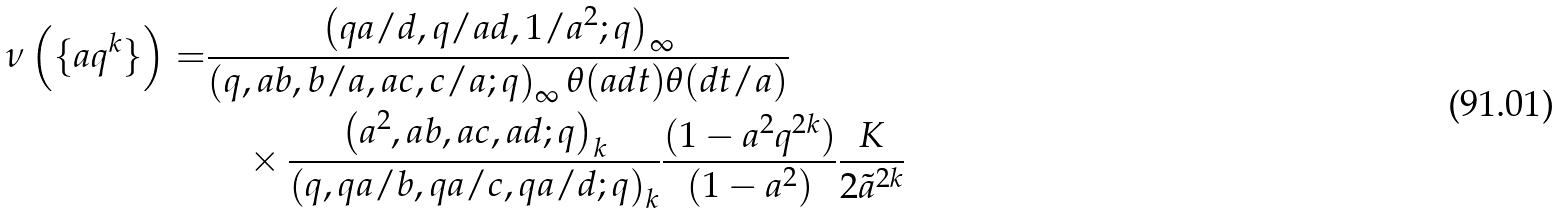Convert formula to latex. <formula><loc_0><loc_0><loc_500><loc_500>\nu \left ( \{ a q ^ { k } \} \right ) = & \frac { \left ( q a / d , q / a d , 1 / a ^ { 2 } ; q \right ) _ { \infty } } { \left ( q , a b , b / a , a c , c / a ; q \right ) _ { \infty } \theta ( a d t ) \theta ( d t / a ) } \\ & \quad \times \frac { \left ( a ^ { 2 } , a b , a c , a d ; q \right ) _ { k } } { \left ( q , q a / b , q a / c , q a / d ; q \right ) _ { k } } \frac { ( 1 - a ^ { 2 } q ^ { 2 k } ) } { ( 1 - a ^ { 2 } ) } \frac { K } { 2 \tilde { a } ^ { 2 k } }</formula> 